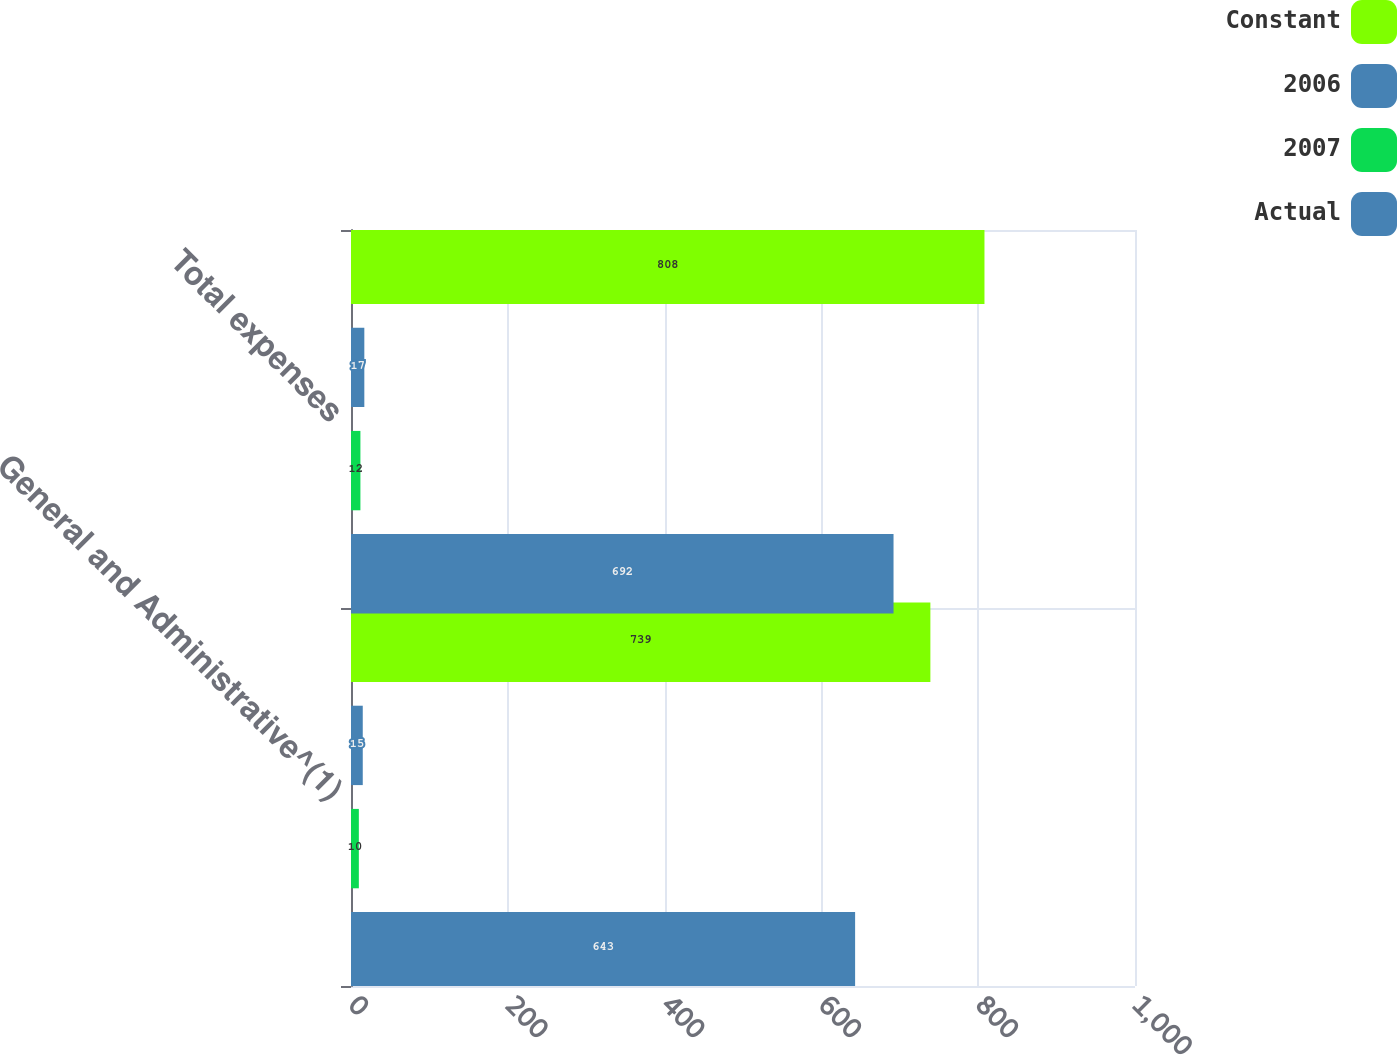Convert chart to OTSL. <chart><loc_0><loc_0><loc_500><loc_500><stacked_bar_chart><ecel><fcel>General and Administrative^(1)<fcel>Total expenses<nl><fcel>Constant<fcel>739<fcel>808<nl><fcel>2006<fcel>15<fcel>17<nl><fcel>2007<fcel>10<fcel>12<nl><fcel>Actual<fcel>643<fcel>692<nl></chart> 